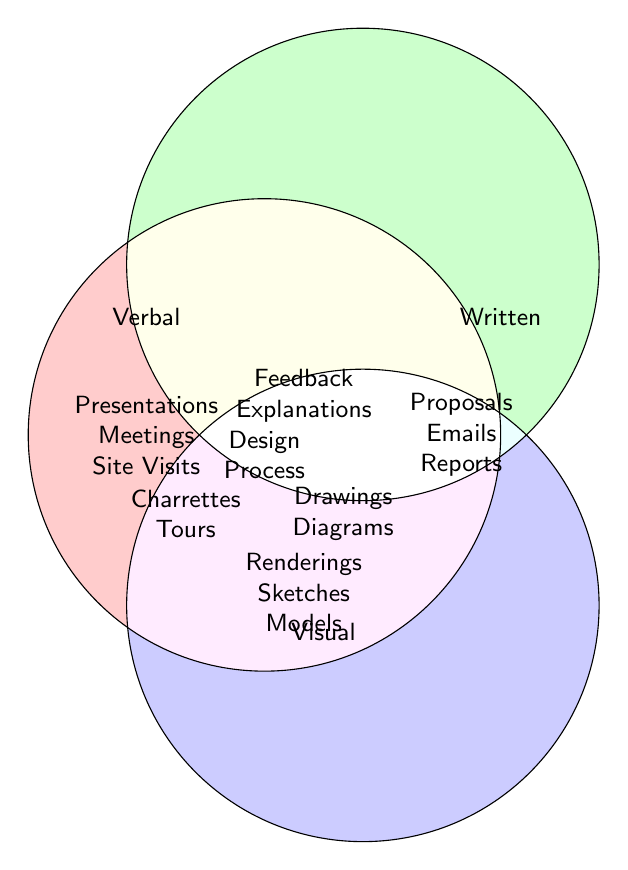What are the three main communication methods highlighted in the diagram? The diagram highlights three communication methods: Verbal, Written, and Visual. These categories are visually distinguished and labeled in different colors.
Answer: Verbal, Written, Visual Which communication method involves "Project Proposals"? "Project Proposals" is associated with the Written communication method. It is placed under the section labeled "Written."
Answer: Written What types of communication methods are combined in the overlapping area that includes "Drawings" and "Diagrams"? The area where "Drawings" and "Diagrams" are shown indicates a combination of Written and Visual communication methods, as it overlaps between their respective circles.
Answer: Written and Visual Which communication methods overlap with "Tours"? "Tours" are found in the intersection of the Verbal and Visual communication methods.
Answer: Verbal and Visual What are the unique communication elements specifically under the Verbal method? Unique elements under the Verbal method include Presentations, Meetings, and Site Visits. These are distinctly placed within the Verbal circle without overlapping with others.
Answer: Presentations, Meetings, Site Visits What is the combined set of communication skills including "Feedback" and "Explanations"? "Feedback" and "Explanations" fall under the intersection of Verbal and Written methods. This denotes that these communications methods require both verbal and written skills.
Answer: Verbal and Written Which section would "Design Process" fall under? "Design Process" is located at the intersection of all three methods: Verbal, Written, and Visual.
Answer: Verbal, Written, Visual Are there more unique communication elements in the Written or Visual category? Both Written and Visual categories have an equal number of unique communication elements when examined: Written has Proposals, Emails, and Reports; Visual has Renderings, Sketches, and Models.
Answer: Equal How many unique communication elements are in the Visual category? The Visual category has three unique elements: Renderings, Sketches, and Models. These are distinct to the Visual circle only.
Answer: 3 